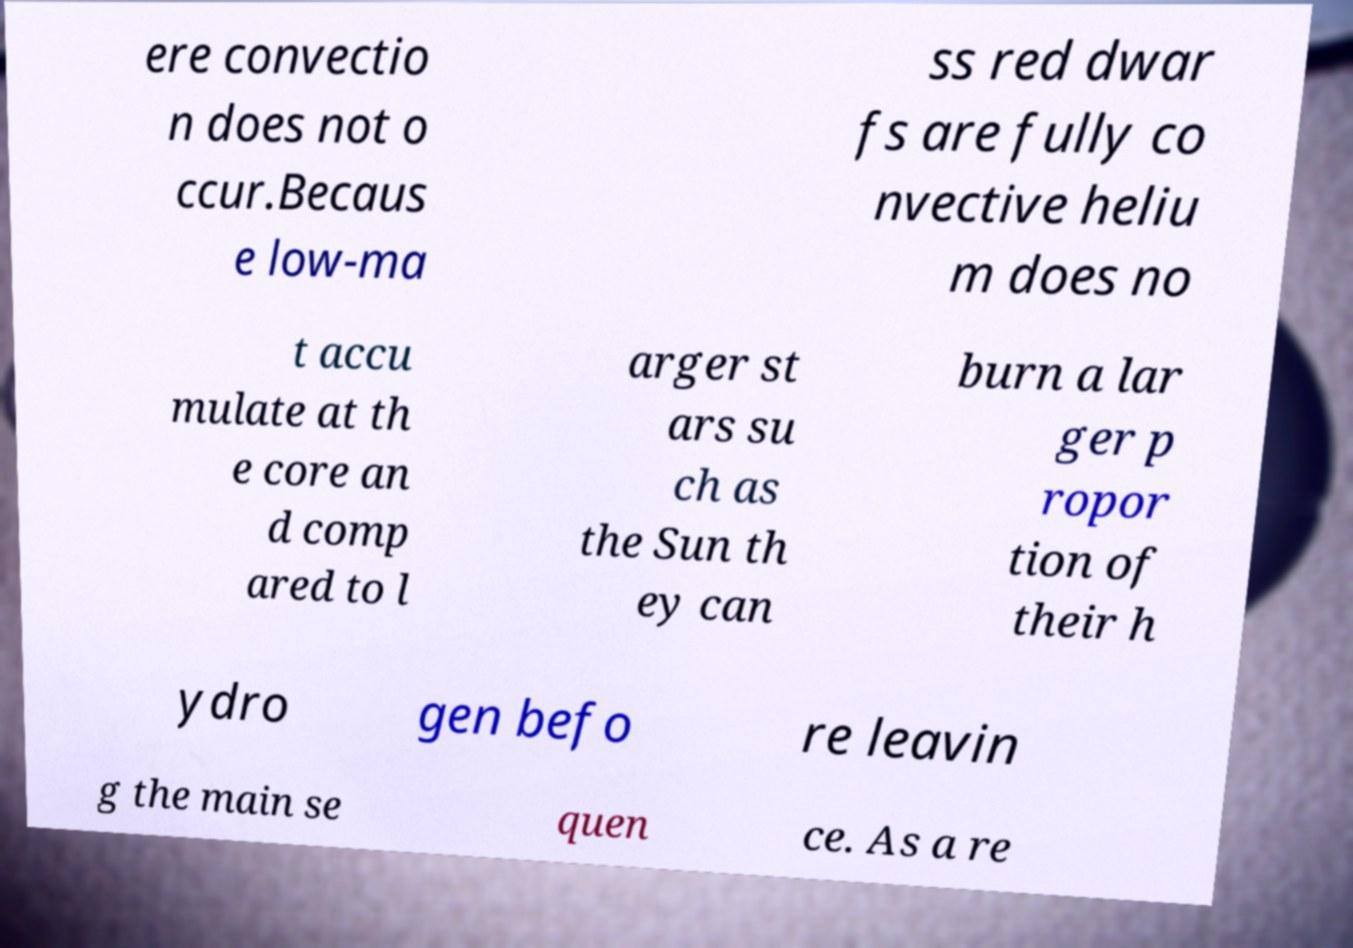What messages or text are displayed in this image? I need them in a readable, typed format. ere convectio n does not o ccur.Becaus e low-ma ss red dwar fs are fully co nvective heliu m does no t accu mulate at th e core an d comp ared to l arger st ars su ch as the Sun th ey can burn a lar ger p ropor tion of their h ydro gen befo re leavin g the main se quen ce. As a re 